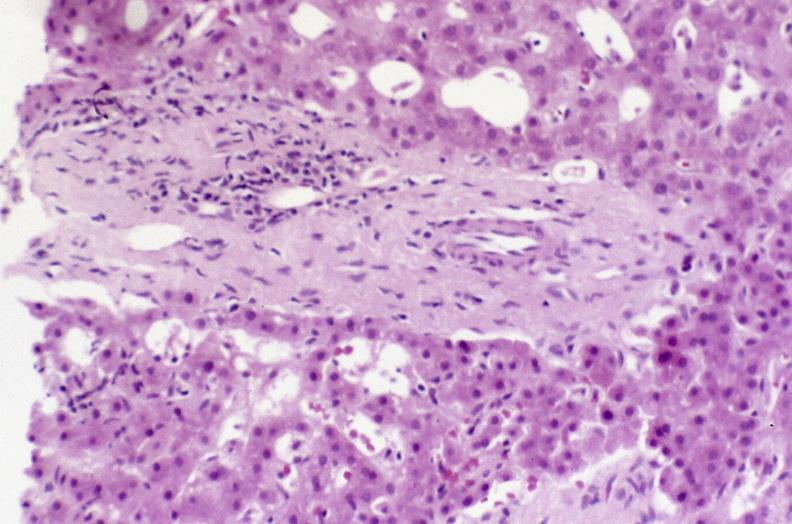what is present?
Answer the question using a single word or phrase. Liver 